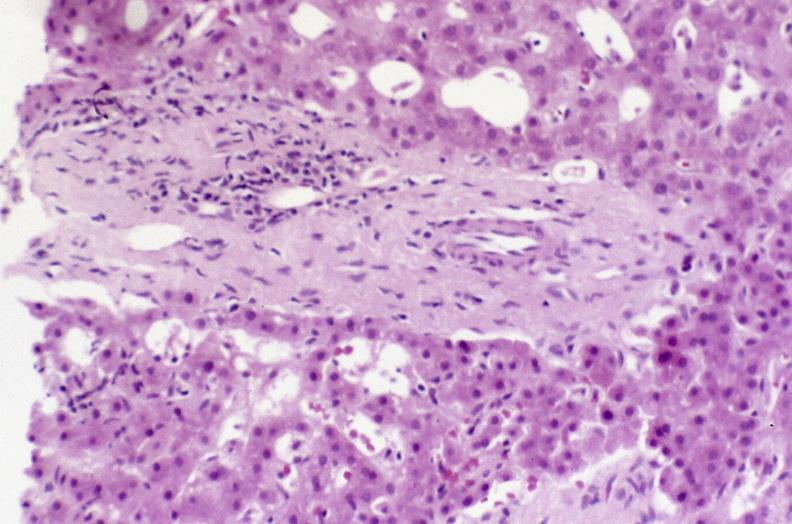what is present?
Answer the question using a single word or phrase. Liver 